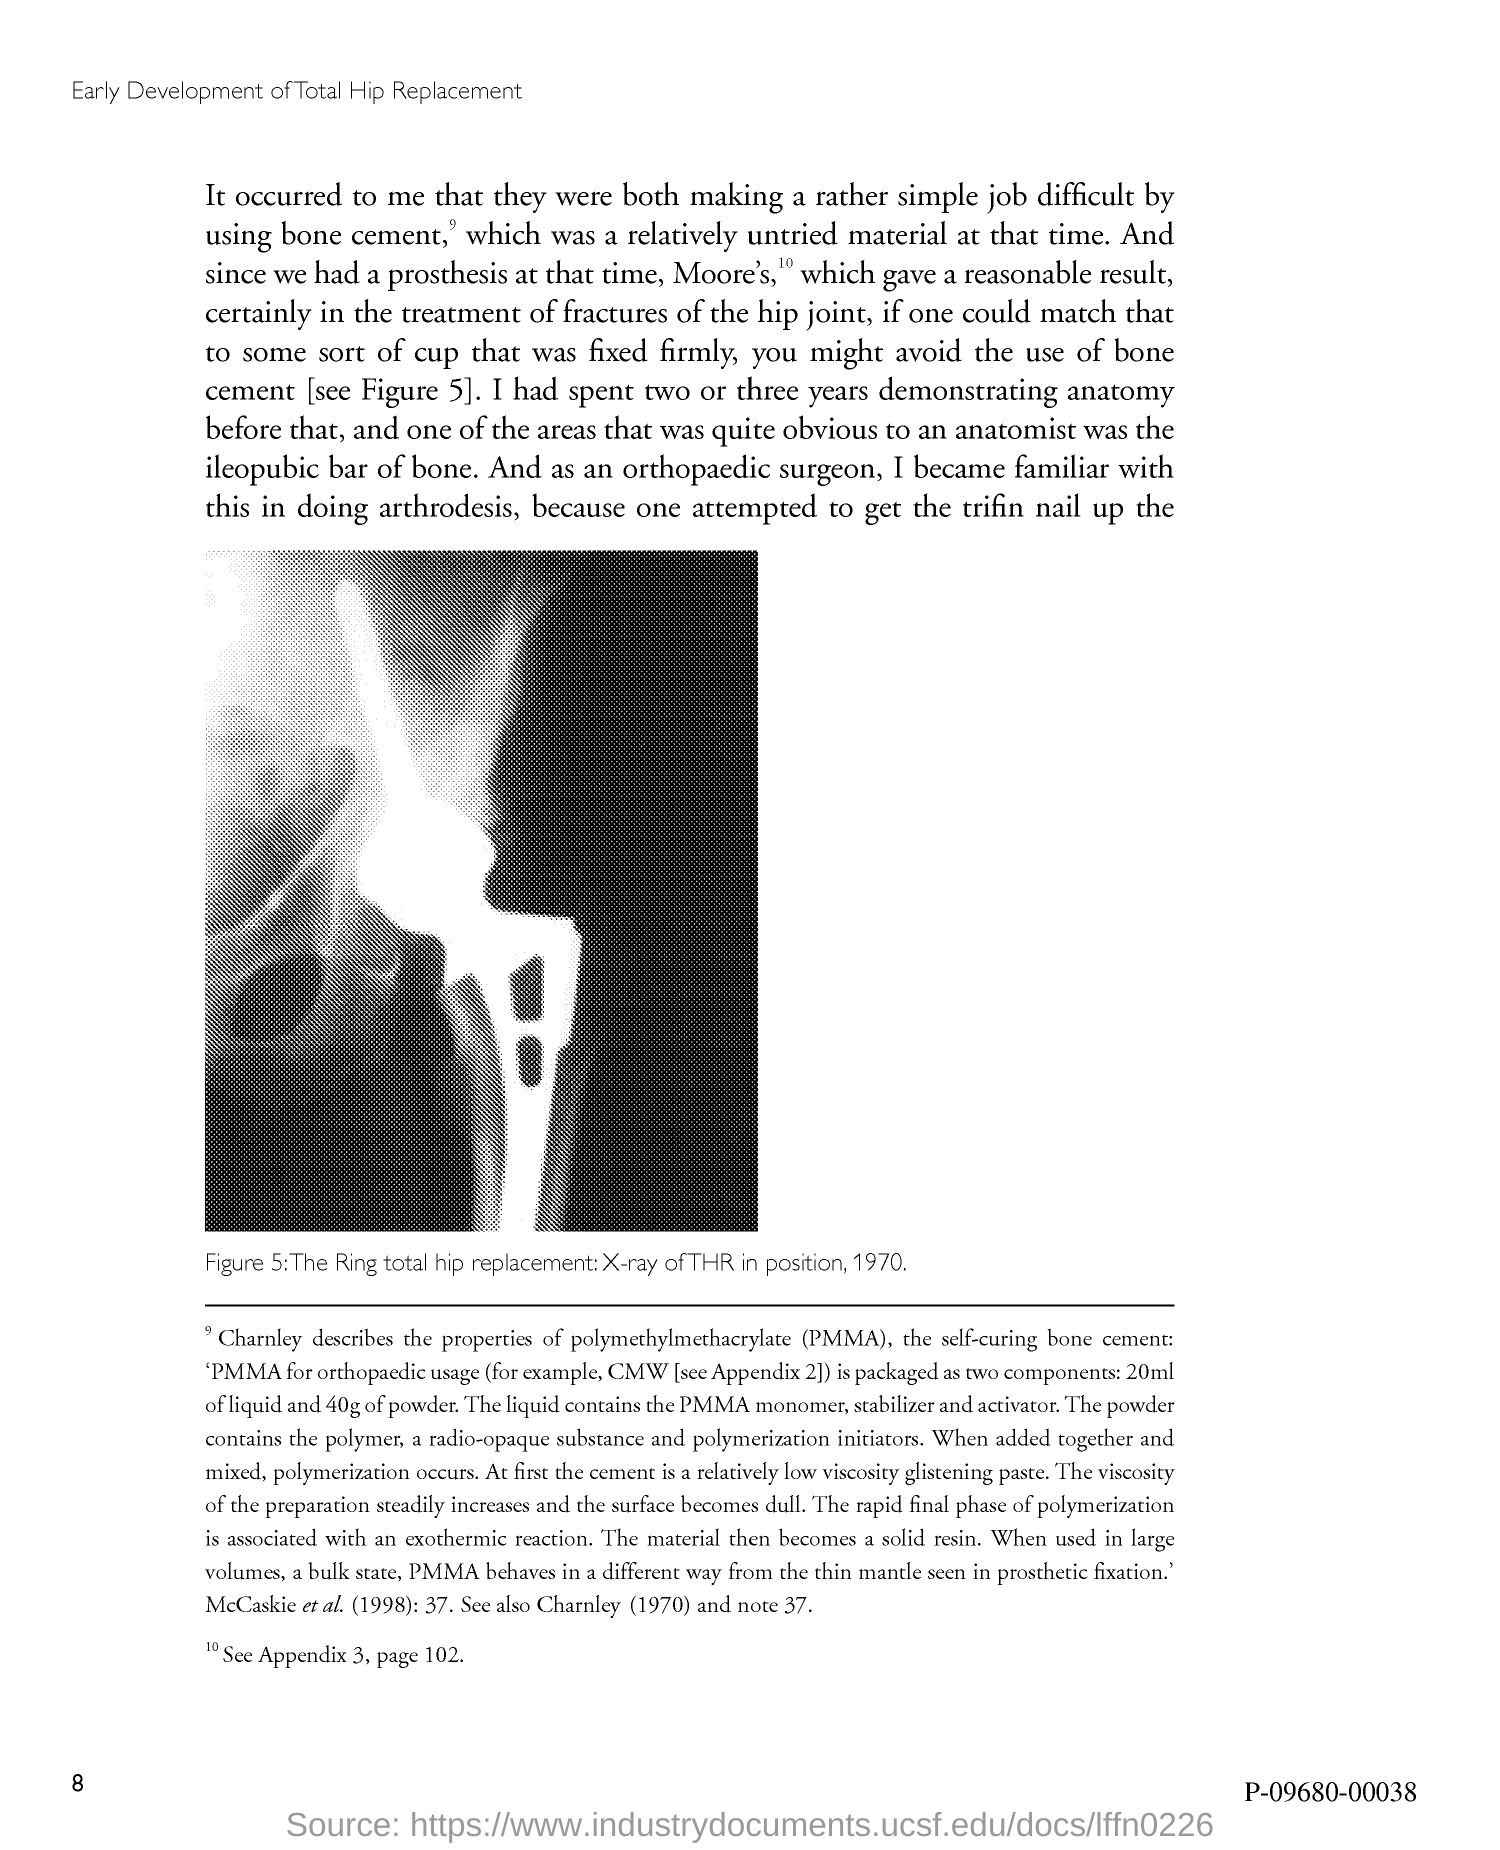Point out several critical features in this image. The full form of PMMA is Polymethylmethacrylate. Figure 5 in this document depicts a radiographic image of a total hip replacement (THR) implant positioned in the ring, as seen in 1970. 